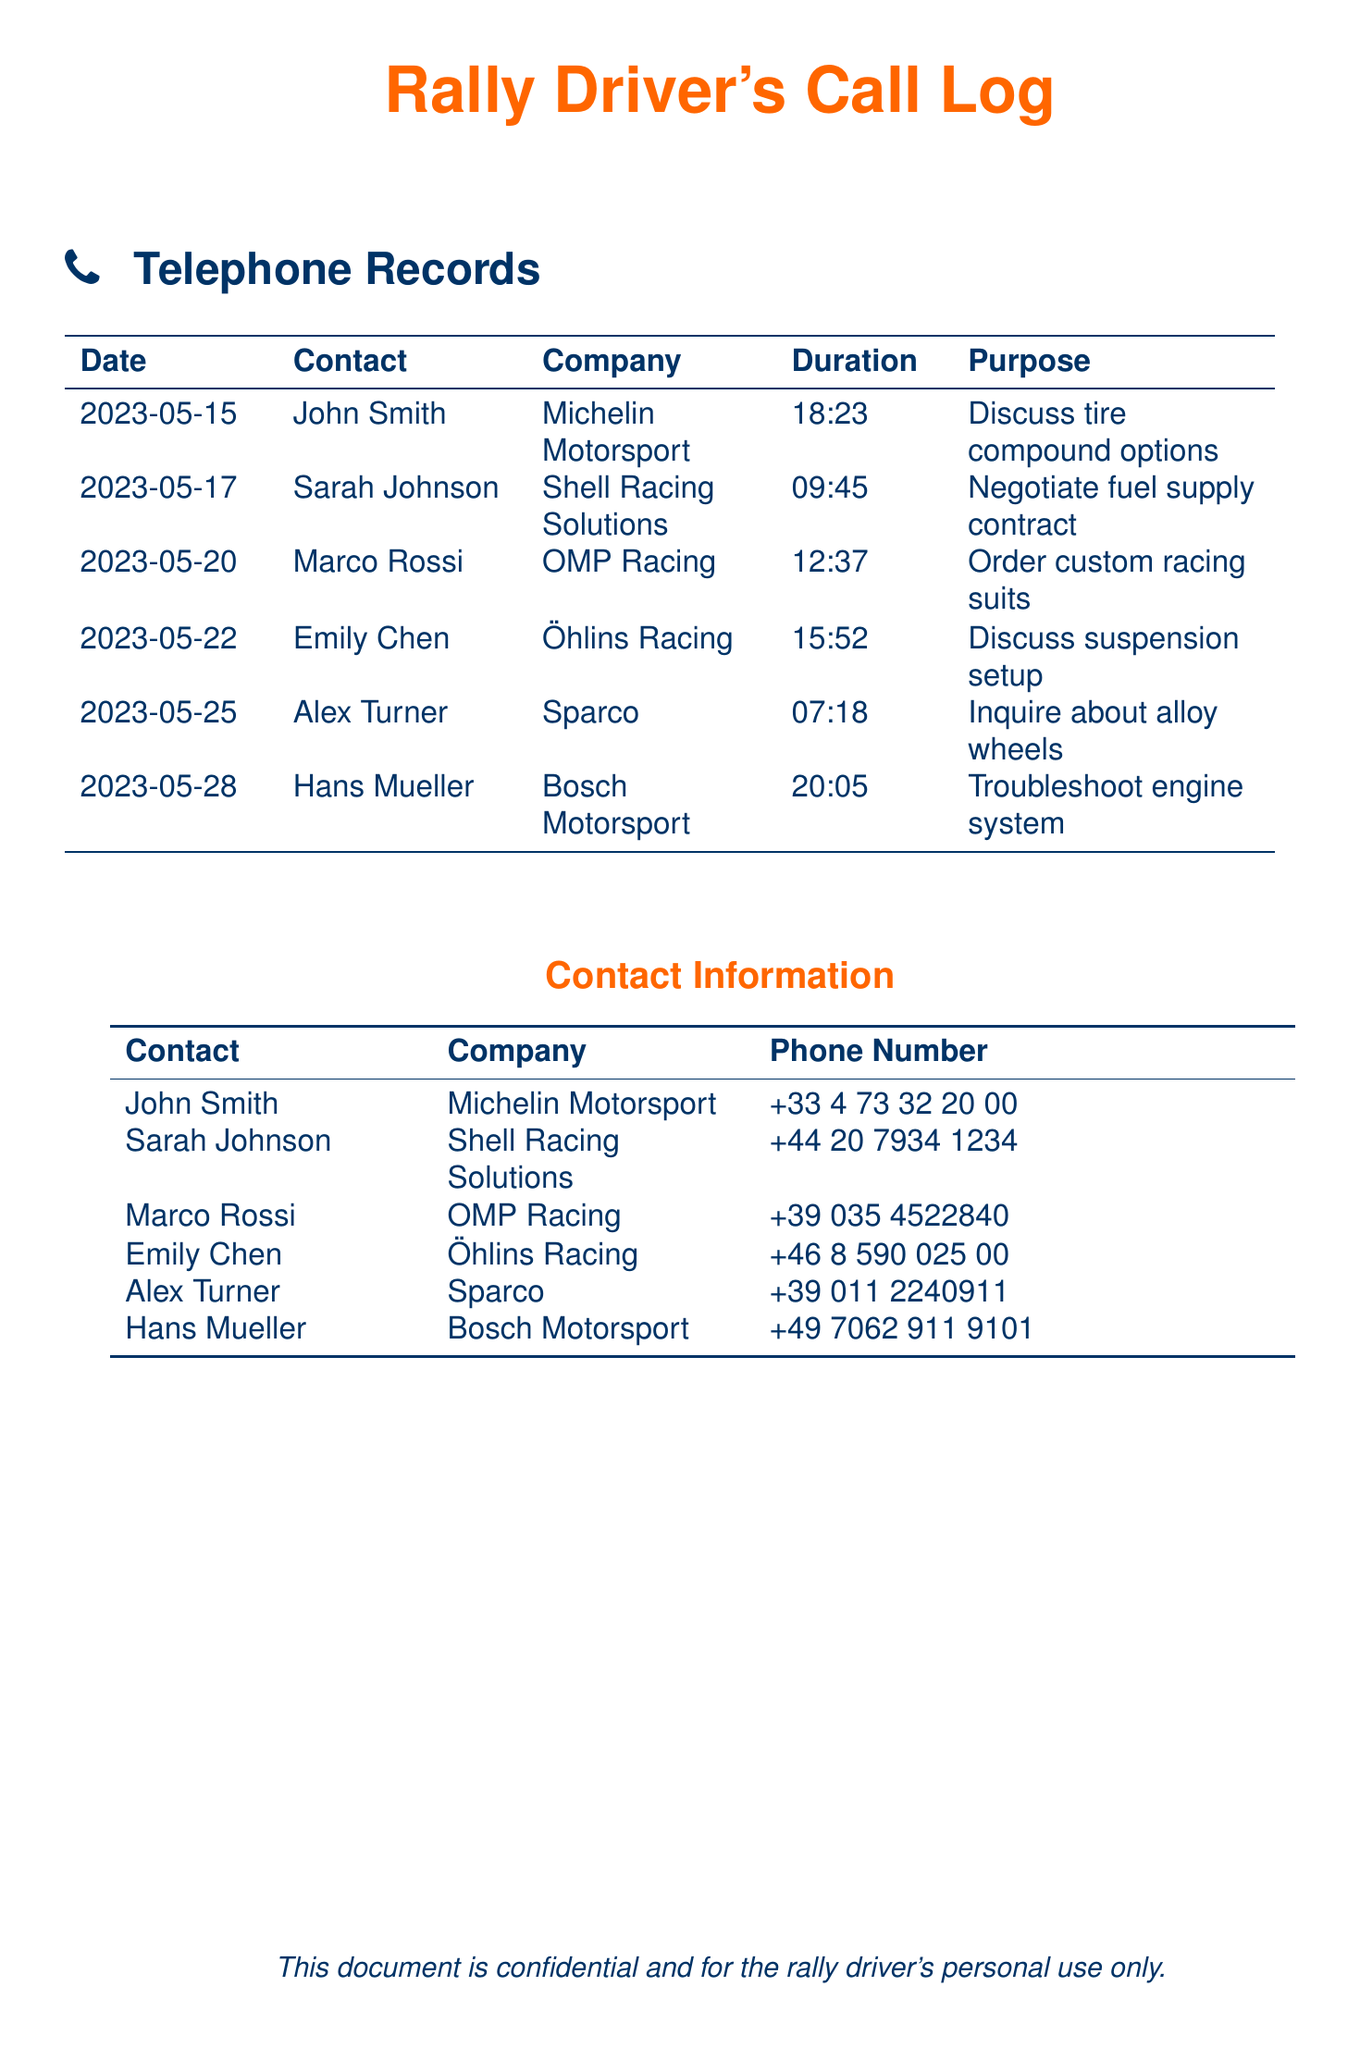What is the date of the call with Sarah Johnson? The call with Sarah Johnson is listed under the date 2023-05-17 in the document.
Answer: 2023-05-17 Which company is associated with Hans Mueller? The document states that Hans Mueller is associated with Bosch Motorsport.
Answer: Bosch Motorsport How long did the call with Marco Rossi last? The call with Marco Rossi lasted for the duration noted in the call log, which is 12:37.
Answer: 12:37 What was the purpose of the call with Emily Chen? The purpose of the call with Emily Chen is outlined as discussing suspension setup in the document.
Answer: Discuss suspension setup Which contact has the phone number +44 20 7934 1234? The phone number +44 20 7934 1234 is associated with Sarah Johnson as shown in the contact information section.
Answer: Sarah Johnson What type of custom order was made with Marco Rossi? The document indicates that the order made with Marco Rossi was for custom racing suits.
Answer: Custom racing suits Which company was involved in troubleshooting the engine system? The document specifies that Bosch Motorsport was involved in troubleshooting the engine system.
Answer: Bosch Motorsport How many minutes did the call with Alex Turner take? The document shows that the call with Alex Turner lasted for 7:18.
Answer: 7:18 